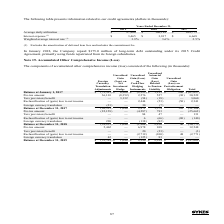According to Sykes Enterprises Incorporated's financial document, What was the interest expense in 2019? According to the financial document, $3,465 (in thousands). The relevant text states: "Interest expense (1) $ 3,465 $ 3,817 $ 6,668..." Also, What does interest expense exclude? the amortization of deferred loan fees and includes the commitment fee.. The document states: "(1) Excludes the amortization of deferred loan fees and includes the commitment fee...." Also, In which years is information related to the credit agreements provided? The document contains multiple relevant values: 2019, 2018, 2017. From the document: "2019 2018 2017 2019 2018 2017 2019 2018 2017..." Additionally, In which year was the amount of Interest expense the smallest? According to the financial document, 2019. The relevant text states: "2019 2018 2017..." Also, can you calculate: What was the change in Interest expense in 2019 from 2018? Based on the calculation: $3,465-$3,817, the result is -352 (in thousands). This is based on the information: "Interest expense (1) $ 3,465 $ 3,817 $ 6,668 Interest expense (1) $ 3,465 $ 3,817 $ 6,668..." The key data points involved are: 3,465, 3,817. Also, can you calculate: What was the percentage change in Interest expense in 2019 from 2018? To answer this question, I need to perform calculations using the financial data. The calculation is: ($3,465-$3,817)/$3,817, which equals -9.22 (percentage). This is based on the information: "Interest expense (1) $ 3,465 $ 3,817 $ 6,668 Interest expense (1) $ 3,465 $ 3,817 $ 6,668..." The key data points involved are: 3,465, 3,817. 